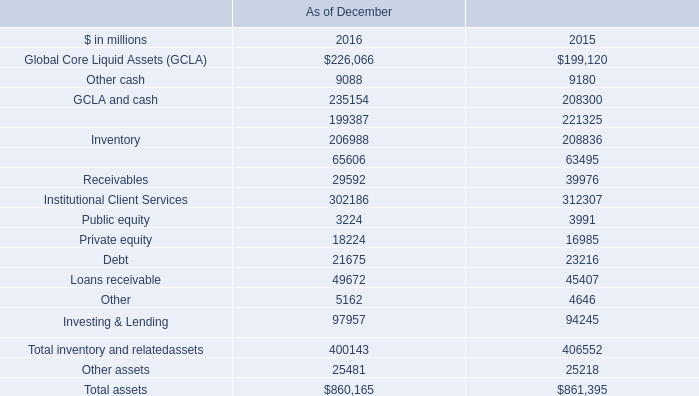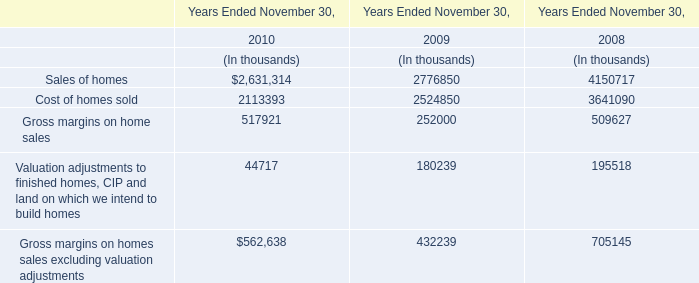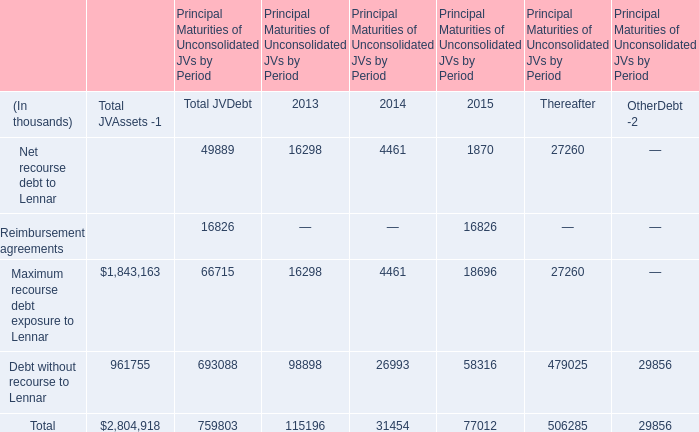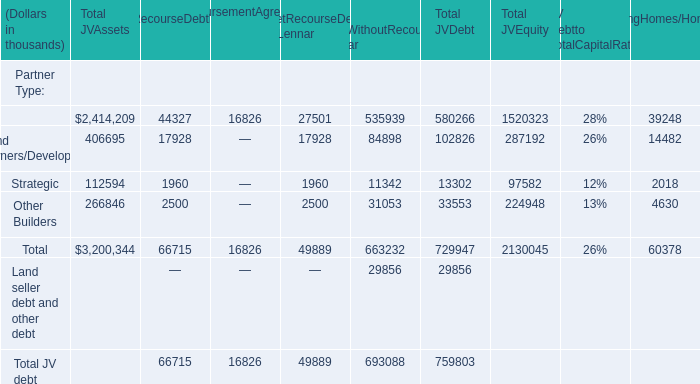What's the average of Inventory of As of December 2015, and Financial of RemainingHomes/Homesitesin JV ? 
Computations: ((208836.0 + 39248.0) / 2)
Answer: 124042.0. 